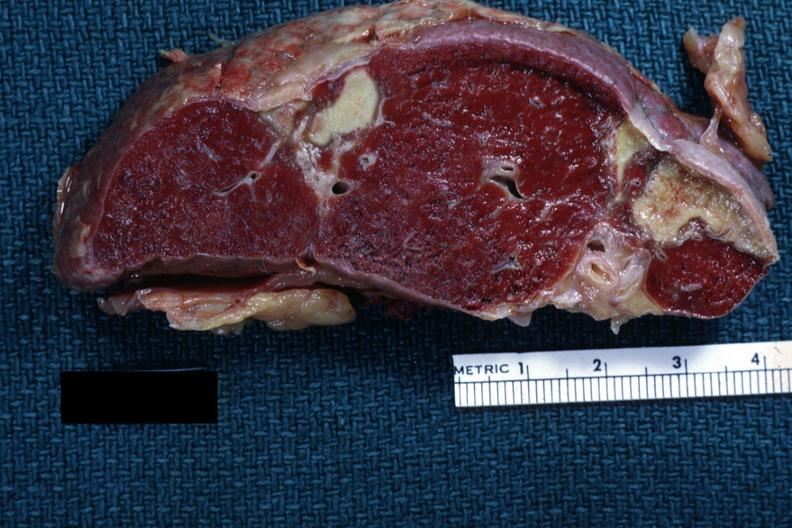where is this part in?
Answer the question using a single word or phrase. Spleen 